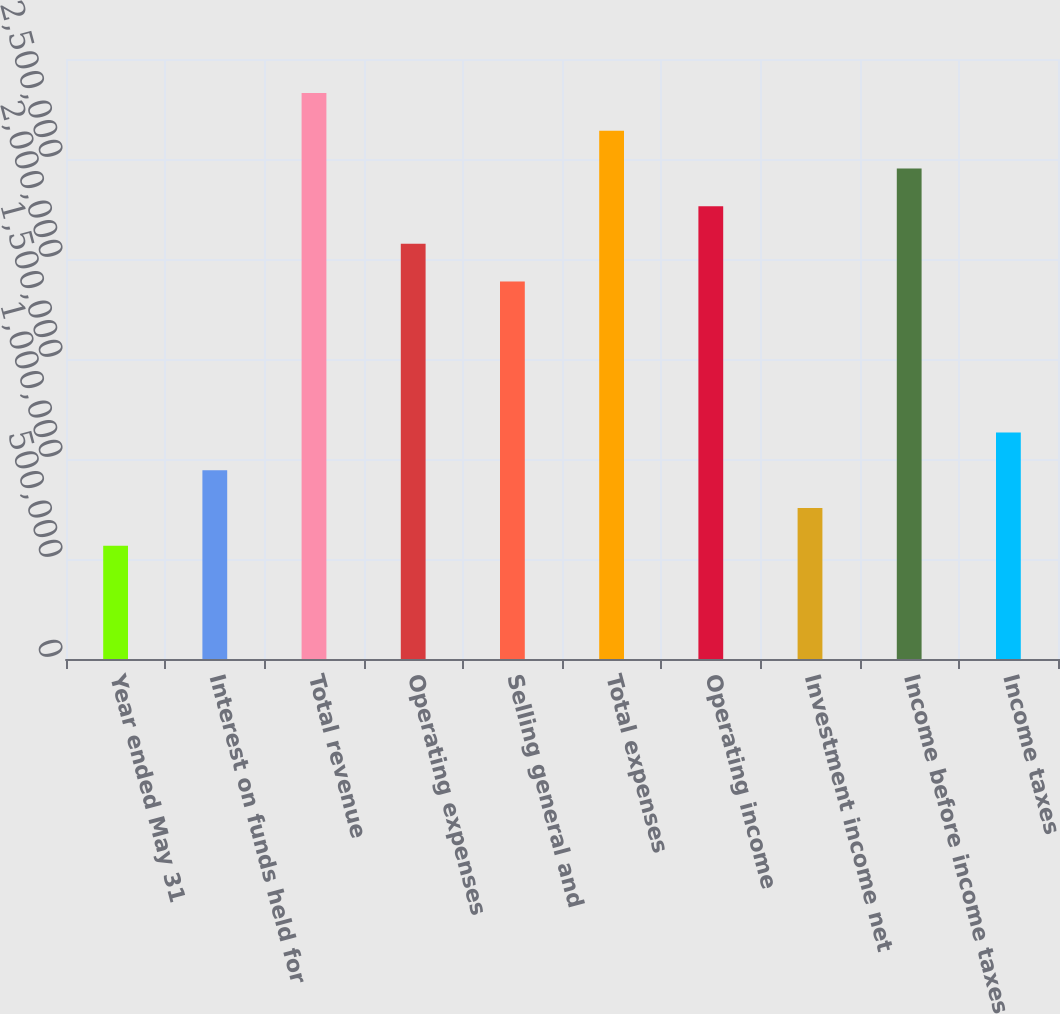Convert chart to OTSL. <chart><loc_0><loc_0><loc_500><loc_500><bar_chart><fcel>Year ended May 31<fcel>Interest on funds held for<fcel>Total revenue<fcel>Operating expenses<fcel>Selling general and<fcel>Total expenses<fcel>Operating income<fcel>Investment income net<fcel>Income before income taxes<fcel>Income taxes<nl><fcel>566090<fcel>943482<fcel>2.83045e+06<fcel>2.07566e+06<fcel>1.88696e+06<fcel>2.64175e+06<fcel>2.26436e+06<fcel>754786<fcel>2.45305e+06<fcel>1.13218e+06<nl></chart> 